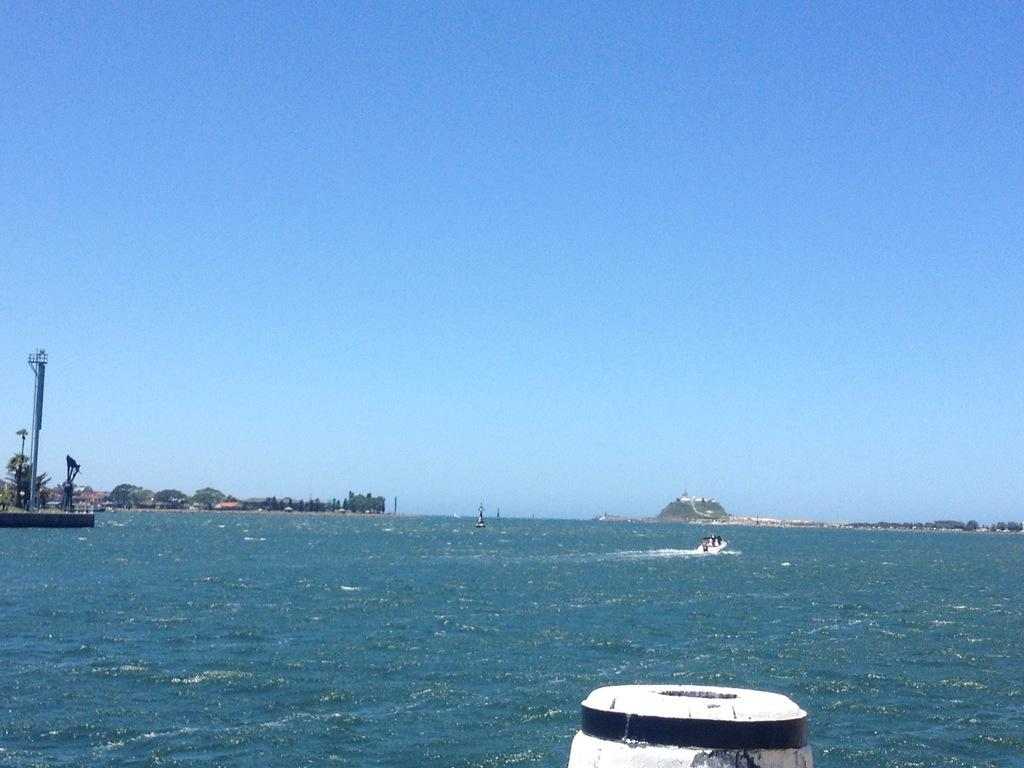What is the main subject of the image? The main subject of the image is a boat. What is the boat doing in the image? The boat is floating on the water in the image. What can be seen on the left side of the image? There are trees and a pole on the left side of the image. What type of water is visible in the image? The image contains an ocean. What is visible in the background of the image? The sky is visible in the background of the image. What type of van can be seen parked near the trees in the image? There is no van present in the image; it features a boat floating on the water and trees on the left side. What things are being cooked in the oven in the image? There is no oven present in the image; it contains a boat, trees, a pole, and an ocean. 